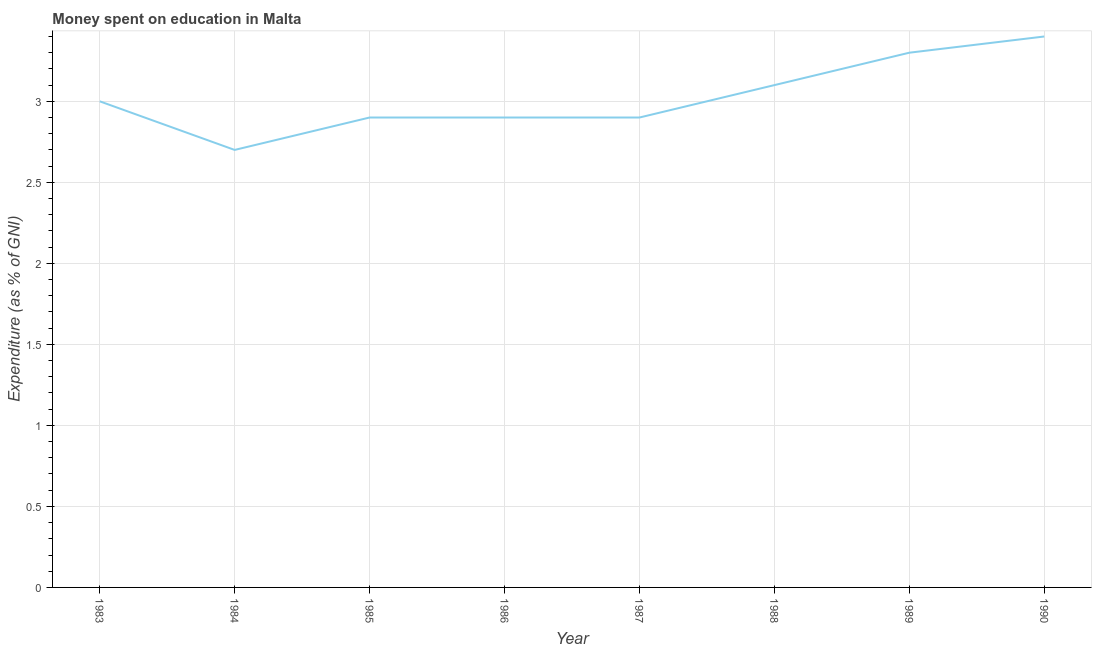In which year was the expenditure on education maximum?
Your answer should be compact. 1990. What is the sum of the expenditure on education?
Make the answer very short. 24.2. What is the difference between the expenditure on education in 1985 and 1988?
Offer a very short reply. -0.2. What is the average expenditure on education per year?
Provide a short and direct response. 3.02. What is the median expenditure on education?
Your answer should be compact. 2.95. In how many years, is the expenditure on education greater than 1.9 %?
Keep it short and to the point. 8. Do a majority of the years between 1990 and 1986 (inclusive) have expenditure on education greater than 2.8 %?
Your answer should be compact. Yes. What is the ratio of the expenditure on education in 1984 to that in 1990?
Provide a succinct answer. 0.79. Is the difference between the expenditure on education in 1984 and 1987 greater than the difference between any two years?
Give a very brief answer. No. What is the difference between the highest and the second highest expenditure on education?
Provide a succinct answer. 0.1. Is the sum of the expenditure on education in 1986 and 1990 greater than the maximum expenditure on education across all years?
Give a very brief answer. Yes. What is the difference between the highest and the lowest expenditure on education?
Give a very brief answer. 0.7. How many lines are there?
Offer a very short reply. 1. How many years are there in the graph?
Offer a very short reply. 8. What is the difference between two consecutive major ticks on the Y-axis?
Make the answer very short. 0.5. Does the graph contain any zero values?
Provide a succinct answer. No. Does the graph contain grids?
Give a very brief answer. Yes. What is the title of the graph?
Make the answer very short. Money spent on education in Malta. What is the label or title of the Y-axis?
Your response must be concise. Expenditure (as % of GNI). What is the Expenditure (as % of GNI) in 1984?
Provide a succinct answer. 2.7. What is the Expenditure (as % of GNI) in 1985?
Offer a very short reply. 2.9. What is the Expenditure (as % of GNI) of 1989?
Your answer should be compact. 3.3. What is the Expenditure (as % of GNI) of 1990?
Ensure brevity in your answer.  3.4. What is the difference between the Expenditure (as % of GNI) in 1983 and 1984?
Your response must be concise. 0.3. What is the difference between the Expenditure (as % of GNI) in 1983 and 1985?
Ensure brevity in your answer.  0.1. What is the difference between the Expenditure (as % of GNI) in 1983 and 1986?
Offer a terse response. 0.1. What is the difference between the Expenditure (as % of GNI) in 1984 and 1985?
Ensure brevity in your answer.  -0.2. What is the difference between the Expenditure (as % of GNI) in 1984 and 1986?
Provide a short and direct response. -0.2. What is the difference between the Expenditure (as % of GNI) in 1984 and 1989?
Your response must be concise. -0.6. What is the difference between the Expenditure (as % of GNI) in 1985 and 1986?
Give a very brief answer. 0. What is the difference between the Expenditure (as % of GNI) in 1985 and 1987?
Your answer should be very brief. 0. What is the difference between the Expenditure (as % of GNI) in 1985 and 1988?
Your answer should be very brief. -0.2. What is the difference between the Expenditure (as % of GNI) in 1986 and 1987?
Keep it short and to the point. 0. What is the difference between the Expenditure (as % of GNI) in 1986 and 1988?
Give a very brief answer. -0.2. What is the difference between the Expenditure (as % of GNI) in 1987 and 1988?
Your response must be concise. -0.2. What is the difference between the Expenditure (as % of GNI) in 1987 and 1989?
Ensure brevity in your answer.  -0.4. What is the difference between the Expenditure (as % of GNI) in 1987 and 1990?
Your response must be concise. -0.5. What is the difference between the Expenditure (as % of GNI) in 1988 and 1989?
Provide a short and direct response. -0.2. What is the difference between the Expenditure (as % of GNI) in 1988 and 1990?
Give a very brief answer. -0.3. What is the ratio of the Expenditure (as % of GNI) in 1983 to that in 1984?
Your response must be concise. 1.11. What is the ratio of the Expenditure (as % of GNI) in 1983 to that in 1985?
Your answer should be compact. 1.03. What is the ratio of the Expenditure (as % of GNI) in 1983 to that in 1986?
Make the answer very short. 1.03. What is the ratio of the Expenditure (as % of GNI) in 1983 to that in 1987?
Offer a very short reply. 1.03. What is the ratio of the Expenditure (as % of GNI) in 1983 to that in 1988?
Your response must be concise. 0.97. What is the ratio of the Expenditure (as % of GNI) in 1983 to that in 1989?
Offer a terse response. 0.91. What is the ratio of the Expenditure (as % of GNI) in 1983 to that in 1990?
Provide a short and direct response. 0.88. What is the ratio of the Expenditure (as % of GNI) in 1984 to that in 1987?
Offer a terse response. 0.93. What is the ratio of the Expenditure (as % of GNI) in 1984 to that in 1988?
Provide a short and direct response. 0.87. What is the ratio of the Expenditure (as % of GNI) in 1984 to that in 1989?
Make the answer very short. 0.82. What is the ratio of the Expenditure (as % of GNI) in 1984 to that in 1990?
Your answer should be very brief. 0.79. What is the ratio of the Expenditure (as % of GNI) in 1985 to that in 1986?
Your answer should be very brief. 1. What is the ratio of the Expenditure (as % of GNI) in 1985 to that in 1988?
Your answer should be compact. 0.94. What is the ratio of the Expenditure (as % of GNI) in 1985 to that in 1989?
Make the answer very short. 0.88. What is the ratio of the Expenditure (as % of GNI) in 1985 to that in 1990?
Provide a short and direct response. 0.85. What is the ratio of the Expenditure (as % of GNI) in 1986 to that in 1987?
Provide a short and direct response. 1. What is the ratio of the Expenditure (as % of GNI) in 1986 to that in 1988?
Offer a terse response. 0.94. What is the ratio of the Expenditure (as % of GNI) in 1986 to that in 1989?
Give a very brief answer. 0.88. What is the ratio of the Expenditure (as % of GNI) in 1986 to that in 1990?
Make the answer very short. 0.85. What is the ratio of the Expenditure (as % of GNI) in 1987 to that in 1988?
Offer a very short reply. 0.94. What is the ratio of the Expenditure (as % of GNI) in 1987 to that in 1989?
Your answer should be very brief. 0.88. What is the ratio of the Expenditure (as % of GNI) in 1987 to that in 1990?
Keep it short and to the point. 0.85. What is the ratio of the Expenditure (as % of GNI) in 1988 to that in 1989?
Your answer should be compact. 0.94. What is the ratio of the Expenditure (as % of GNI) in 1988 to that in 1990?
Your answer should be compact. 0.91. 